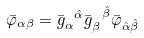<formula> <loc_0><loc_0><loc_500><loc_500>\bar { \varphi } _ { \alpha \beta } = \bar { g } _ { \alpha } ^ { \ \hat { \alpha } } \bar { g } _ { \beta } ^ { \ \hat { \beta } } \bar { \varphi } _ { \hat { \alpha } \hat { \beta } }</formula> 